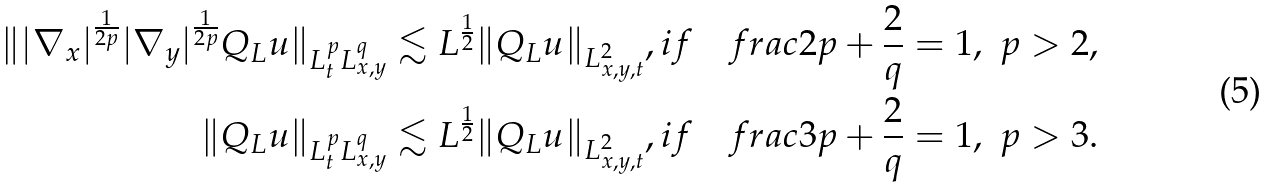Convert formula to latex. <formula><loc_0><loc_0><loc_500><loc_500>\| | \nabla _ { x } | ^ { \frac { 1 } { 2 p } } | \nabla _ { y } | ^ { \frac { 1 } { 2 p } } Q _ { L } u \| _ { L _ { t } ^ { p } L _ { x , y } ^ { q } } & \lesssim L ^ { \frac { 1 } { 2 } } \| Q _ { L } u \| _ { L ^ { 2 } _ { x , y , t } } , i f \quad f r a c { 2 } { p } + \frac { 2 } { q } = 1 , \ p > 2 , \\ \| Q _ { L } u \| _ { L _ { t } ^ { p } L _ { x , y } ^ { q } } & \lesssim L ^ { \frac { 1 } { 2 } } \| Q _ { L } u \| _ { L ^ { 2 } _ { x , y , t } } , i f \quad f r a c { 3 } { p } + \frac { 2 } { q } = 1 , \ p > 3 .</formula> 